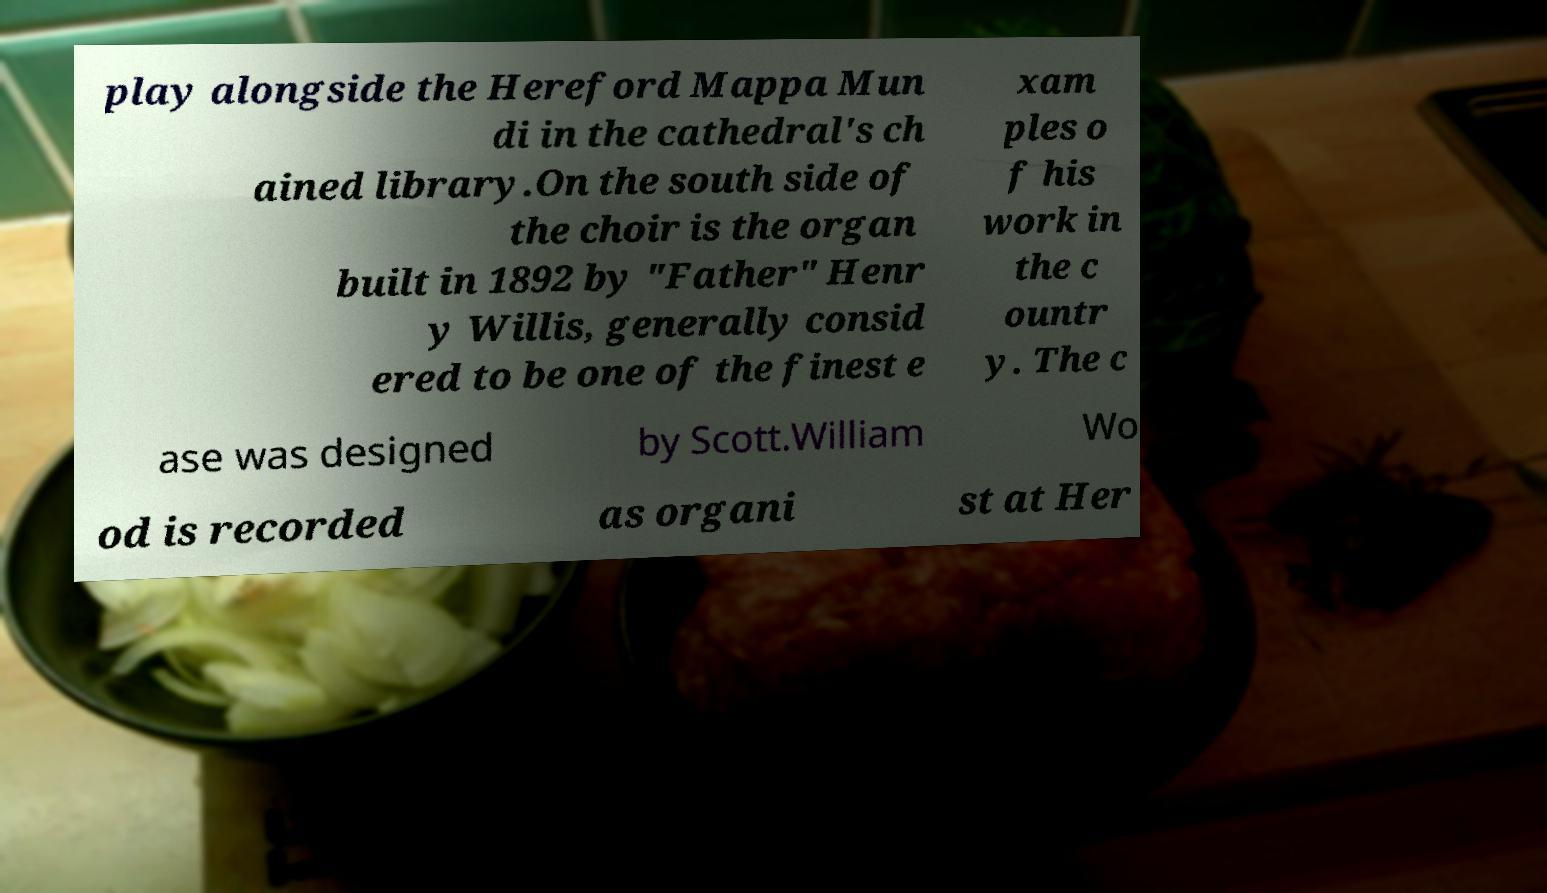There's text embedded in this image that I need extracted. Can you transcribe it verbatim? play alongside the Hereford Mappa Mun di in the cathedral's ch ained library.On the south side of the choir is the organ built in 1892 by "Father" Henr y Willis, generally consid ered to be one of the finest e xam ples o f his work in the c ountr y. The c ase was designed by Scott.William Wo od is recorded as organi st at Her 